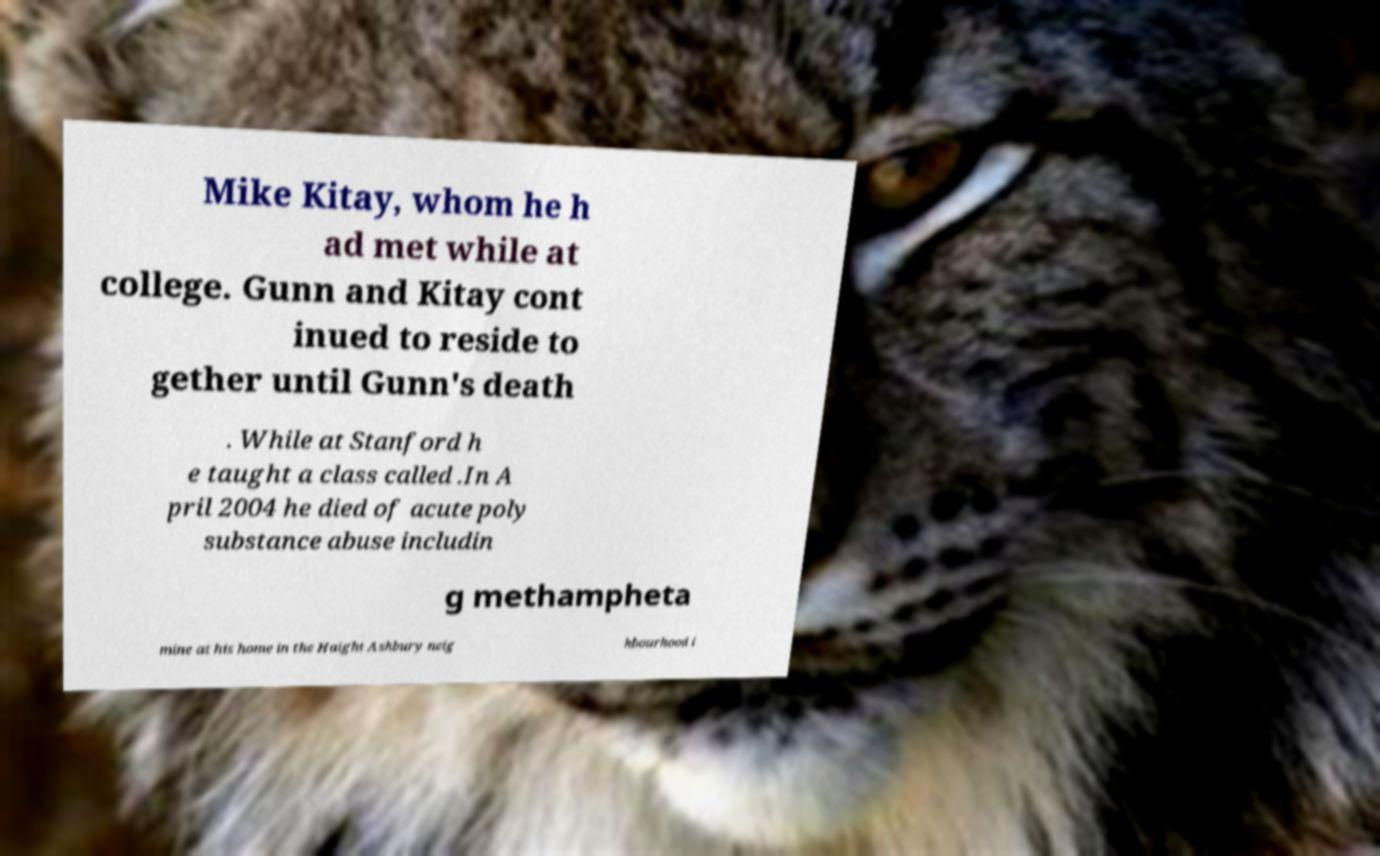There's text embedded in this image that I need extracted. Can you transcribe it verbatim? Mike Kitay, whom he h ad met while at college. Gunn and Kitay cont inued to reside to gether until Gunn's death . While at Stanford h e taught a class called .In A pril 2004 he died of acute poly substance abuse includin g methampheta mine at his home in the Haight Ashbury neig hbourhood i 